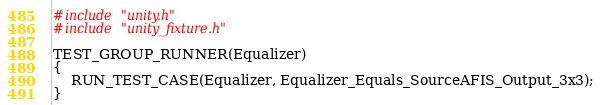<code> <loc_0><loc_0><loc_500><loc_500><_C_>#include "unity.h"
#include "unity_fixture.h"

TEST_GROUP_RUNNER(Equalizer)
{
    RUN_TEST_CASE(Equalizer, Equalizer_Equals_SourceAFIS_Output_3x3);
}
</code> 